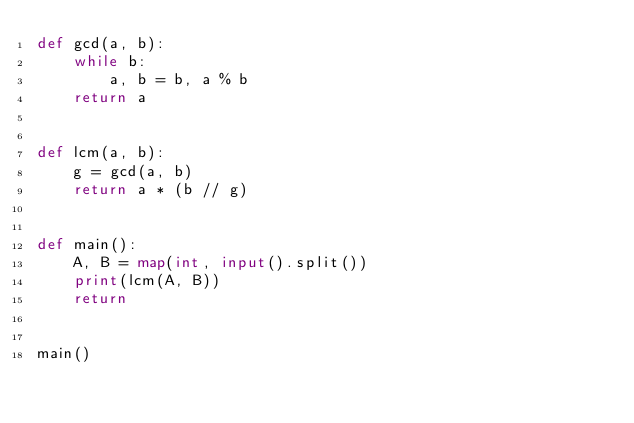<code> <loc_0><loc_0><loc_500><loc_500><_Python_>def gcd(a, b):
    while b:
        a, b = b, a % b
    return a


def lcm(a, b):
    g = gcd(a, b)
    return a * (b // g)


def main():
    A, B = map(int, input().split())
    print(lcm(A, B))
    return


main()
</code> 